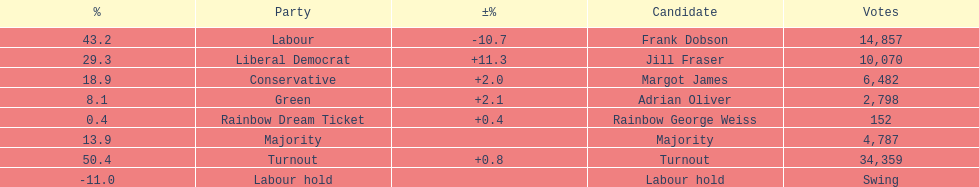How many votes did both the conservative party and the rainbow dream ticket party receive? 6634. 